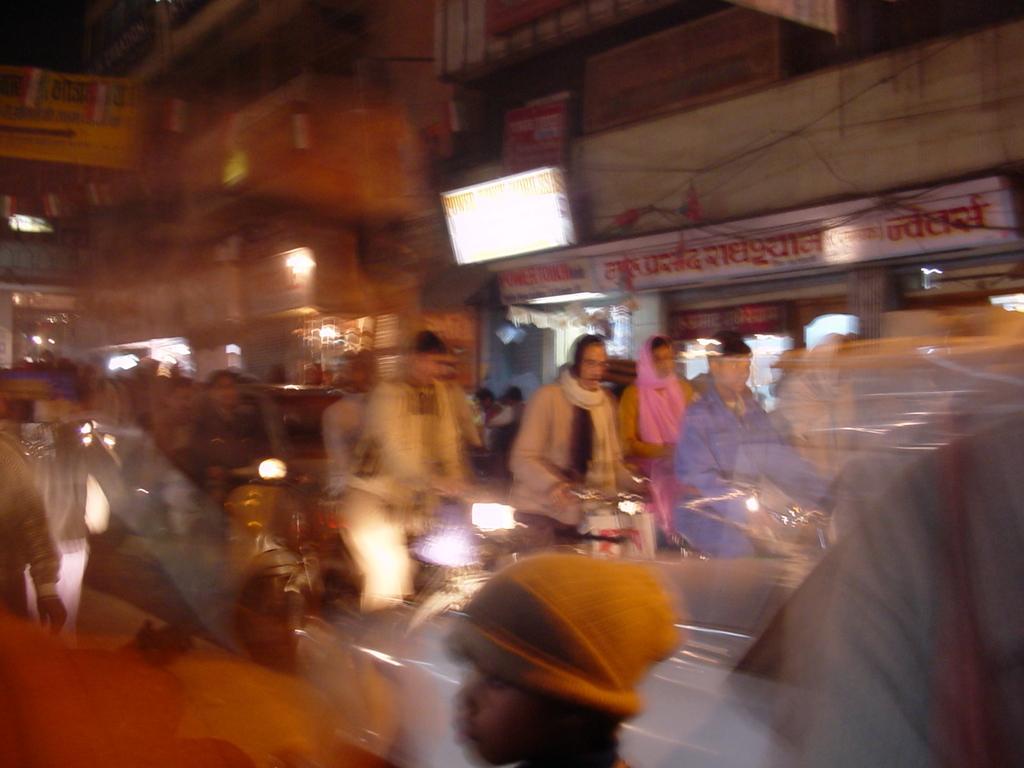How would you summarize this image in a sentence or two? There are persons cycling on the road. There is a person riding a bike on the road. In the background, there is a hoarding attached to the wall of a building, there are lights and there are buildings. And some part of this image is blurred. 